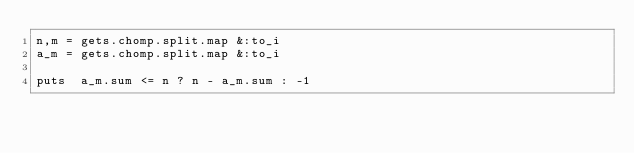<code> <loc_0><loc_0><loc_500><loc_500><_Ruby_>n,m = gets.chomp.split.map &:to_i
a_m = gets.chomp.split.map &:to_i

puts  a_m.sum <= n ? n - a_m.sum : -1
</code> 